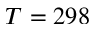<formula> <loc_0><loc_0><loc_500><loc_500>T = 2 9 8</formula> 